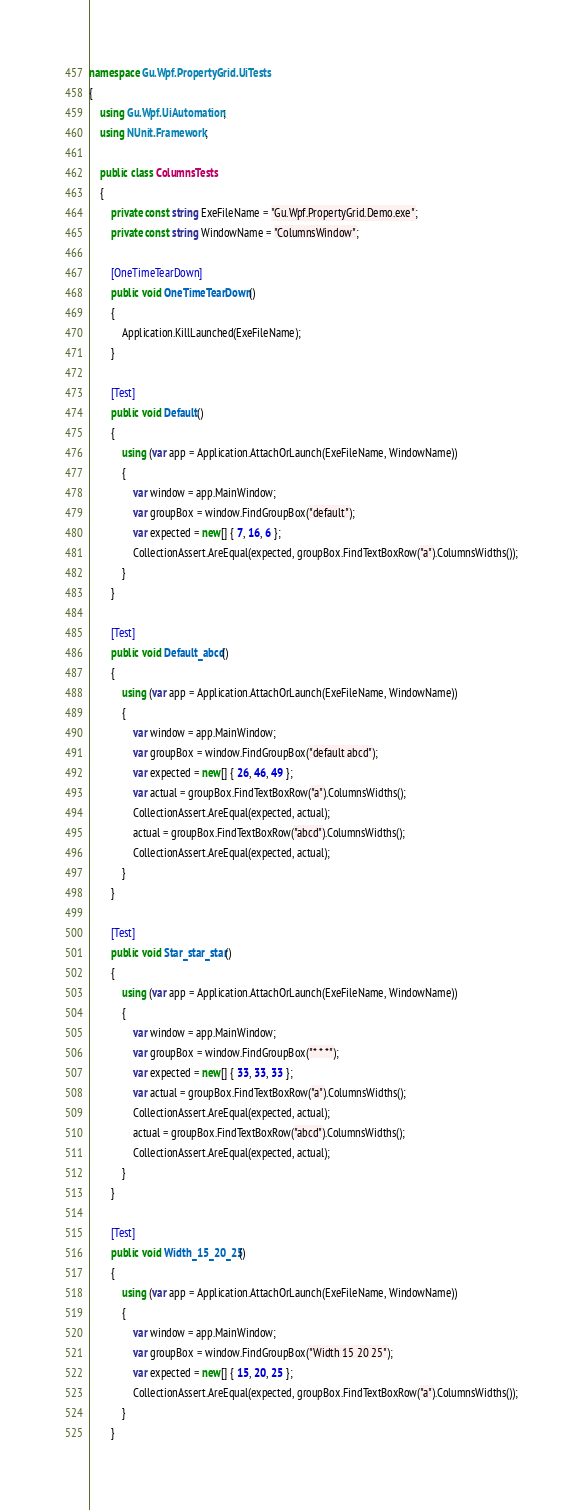<code> <loc_0><loc_0><loc_500><loc_500><_C#_>namespace Gu.Wpf.PropertyGrid.UiTests
{
    using Gu.Wpf.UiAutomation;
    using NUnit.Framework;

    public class ColumnsTests
    {
        private const string ExeFileName = "Gu.Wpf.PropertyGrid.Demo.exe";
        private const string WindowName = "ColumnsWindow";

        [OneTimeTearDown]
        public void OneTimeTearDown()
        {
            Application.KillLaunched(ExeFileName);
        }

        [Test]
        public void Default()
        {
            using (var app = Application.AttachOrLaunch(ExeFileName, WindowName))
            {
                var window = app.MainWindow;
                var groupBox = window.FindGroupBox("default");
                var expected = new[] { 7, 16, 6 };
                CollectionAssert.AreEqual(expected, groupBox.FindTextBoxRow("a").ColumnsWidths());
            }
        }

        [Test]
        public void Default_abcd()
        {
            using (var app = Application.AttachOrLaunch(ExeFileName, WindowName))
            {
                var window = app.MainWindow;
                var groupBox = window.FindGroupBox("default abcd");
                var expected = new[] { 26, 46, 49 };
                var actual = groupBox.FindTextBoxRow("a").ColumnsWidths();
                CollectionAssert.AreEqual(expected, actual);
                actual = groupBox.FindTextBoxRow("abcd").ColumnsWidths();
                CollectionAssert.AreEqual(expected, actual);
            }
        }

        [Test]
        public void Star_star_star()
        {
            using (var app = Application.AttachOrLaunch(ExeFileName, WindowName))
            {
                var window = app.MainWindow;
                var groupBox = window.FindGroupBox("* * *");
                var expected = new[] { 33, 33, 33 };
                var actual = groupBox.FindTextBoxRow("a").ColumnsWidths();
                CollectionAssert.AreEqual(expected, actual);
                actual = groupBox.FindTextBoxRow("abcd").ColumnsWidths();
                CollectionAssert.AreEqual(expected, actual);
            }
        }

        [Test]
        public void Width_15_20_25()
        {
            using (var app = Application.AttachOrLaunch(ExeFileName, WindowName))
            {
                var window = app.MainWindow;
                var groupBox = window.FindGroupBox("Width 15 20 25");
                var expected = new[] { 15, 20, 25 };
                CollectionAssert.AreEqual(expected, groupBox.FindTextBoxRow("a").ColumnsWidths());
            }
        }
</code> 